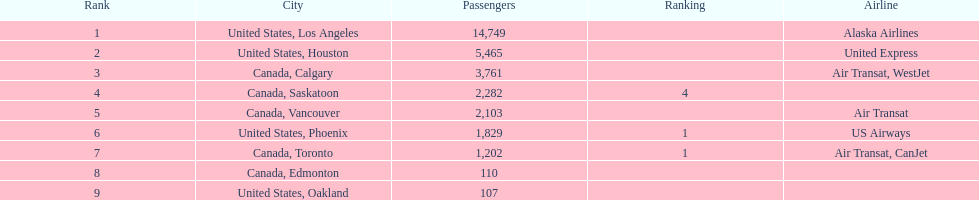Help me parse the entirety of this table. {'header': ['Rank', 'City', 'Passengers', 'Ranking', 'Airline'], 'rows': [['1', 'United States, Los Angeles', '14,749', '', 'Alaska Airlines'], ['2', 'United States, Houston', '5,465', '', 'United Express'], ['3', 'Canada, Calgary', '3,761', '', 'Air Transat, WestJet'], ['4', 'Canada, Saskatoon', '2,282', '4', ''], ['5', 'Canada, Vancouver', '2,103', '', 'Air Transat'], ['6', 'United States, Phoenix', '1,829', '1', 'US Airways'], ['7', 'Canada, Toronto', '1,202', '1', 'Air Transat, CanJet'], ['8', 'Canada, Edmonton', '110', '', ''], ['9', 'United States, Oakland', '107', '', '']]} The least number of passengers came from which city United States, Oakland. 